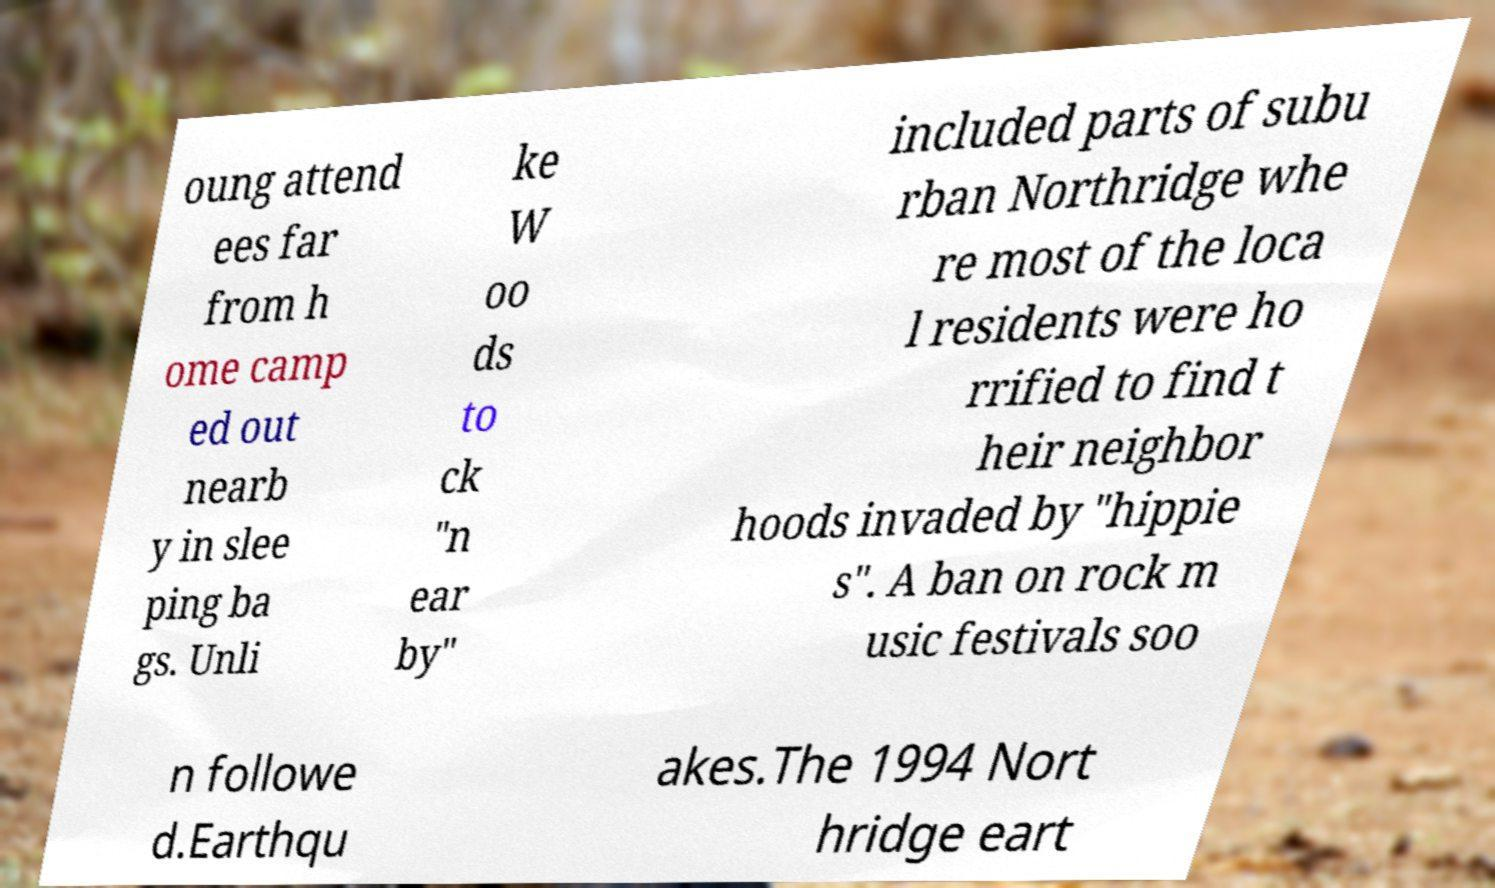Can you read and provide the text displayed in the image?This photo seems to have some interesting text. Can you extract and type it out for me? oung attend ees far from h ome camp ed out nearb y in slee ping ba gs. Unli ke W oo ds to ck "n ear by" included parts of subu rban Northridge whe re most of the loca l residents were ho rrified to find t heir neighbor hoods invaded by "hippie s". A ban on rock m usic festivals soo n followe d.Earthqu akes.The 1994 Nort hridge eart 